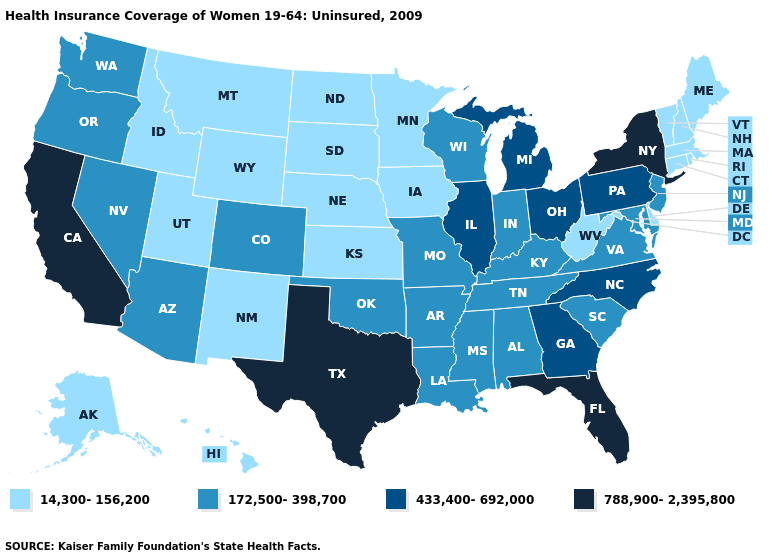Which states have the lowest value in the South?
Quick response, please. Delaware, West Virginia. Name the states that have a value in the range 433,400-692,000?
Give a very brief answer. Georgia, Illinois, Michigan, North Carolina, Ohio, Pennsylvania. What is the value of New Mexico?
Keep it brief. 14,300-156,200. Does the map have missing data?
Keep it brief. No. What is the value of Louisiana?
Concise answer only. 172,500-398,700. What is the value of Nevada?
Concise answer only. 172,500-398,700. What is the value of Montana?
Write a very short answer. 14,300-156,200. How many symbols are there in the legend?
Short answer required. 4. What is the value of Oklahoma?
Keep it brief. 172,500-398,700. Does Kansas have the highest value in the MidWest?
Write a very short answer. No. Which states have the lowest value in the USA?
Give a very brief answer. Alaska, Connecticut, Delaware, Hawaii, Idaho, Iowa, Kansas, Maine, Massachusetts, Minnesota, Montana, Nebraska, New Hampshire, New Mexico, North Dakota, Rhode Island, South Dakota, Utah, Vermont, West Virginia, Wyoming. Does the map have missing data?
Quick response, please. No. What is the value of Colorado?
Be succinct. 172,500-398,700. What is the value of Virginia?
Write a very short answer. 172,500-398,700. Does Oregon have the highest value in the USA?
Give a very brief answer. No. 